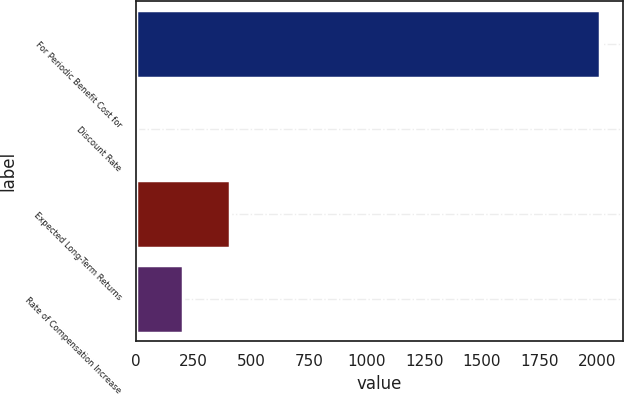Convert chart. <chart><loc_0><loc_0><loc_500><loc_500><bar_chart><fcel>For Periodic Benefit Cost for<fcel>Discount Rate<fcel>Expected Long-Term Returns<fcel>Rate of Compensation Increase<nl><fcel>2013<fcel>4.18<fcel>405.94<fcel>205.06<nl></chart> 